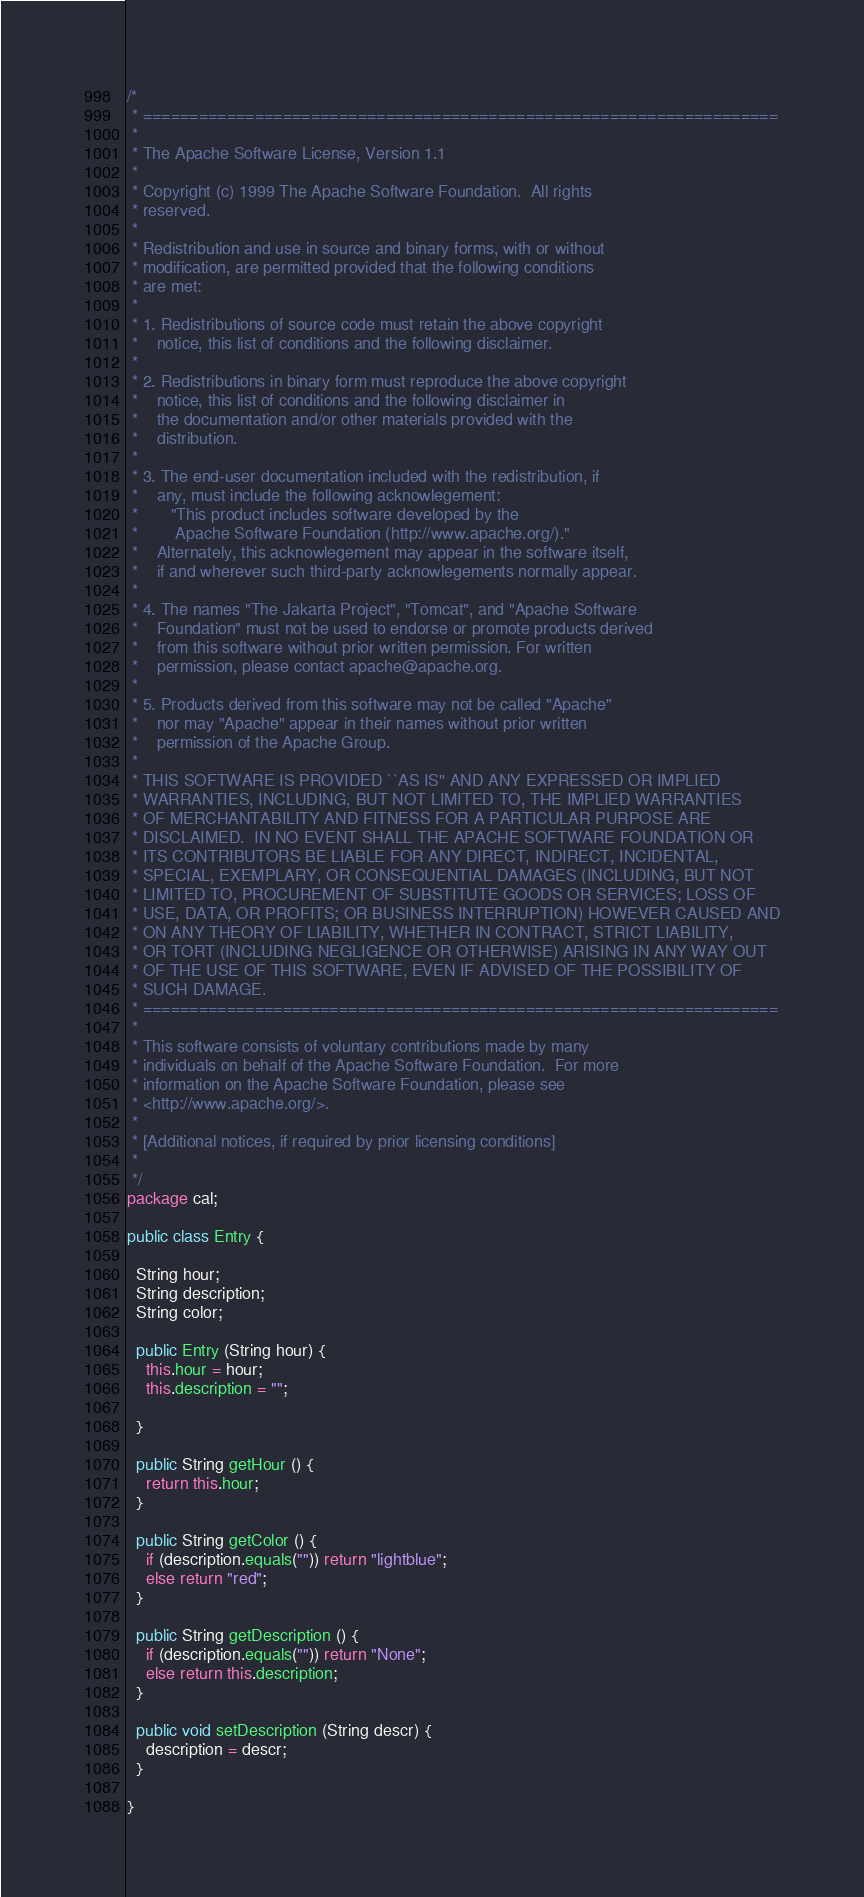<code> <loc_0><loc_0><loc_500><loc_500><_Java_>/*
 * ====================================================================
 *
 * The Apache Software License, Version 1.1
 *
 * Copyright (c) 1999 The Apache Software Foundation.  All rights 
 * reserved.
 *
 * Redistribution and use in source and binary forms, with or without
 * modification, are permitted provided that the following conditions
 * are met:
 *
 * 1. Redistributions of source code must retain the above copyright
 *    notice, this list of conditions and the following disclaimer. 
 *
 * 2. Redistributions in binary form must reproduce the above copyright
 *    notice, this list of conditions and the following disclaimer in
 *    the documentation and/or other materials provided with the
 *    distribution.
 *
 * 3. The end-user documentation included with the redistribution, if
 *    any, must include the following acknowlegement:  
 *       "This product includes software developed by the 
 *        Apache Software Foundation (http://www.apache.org/)."
 *    Alternately, this acknowlegement may appear in the software itself,
 *    if and wherever such third-party acknowlegements normally appear.
 *
 * 4. The names "The Jakarta Project", "Tomcat", and "Apache Software
 *    Foundation" must not be used to endorse or promote products derived
 *    from this software without prior written permission. For written 
 *    permission, please contact apache@apache.org.
 *
 * 5. Products derived from this software may not be called "Apache"
 *    nor may "Apache" appear in their names without prior written
 *    permission of the Apache Group.
 *
 * THIS SOFTWARE IS PROVIDED ``AS IS'' AND ANY EXPRESSED OR IMPLIED
 * WARRANTIES, INCLUDING, BUT NOT LIMITED TO, THE IMPLIED WARRANTIES
 * OF MERCHANTABILITY AND FITNESS FOR A PARTICULAR PURPOSE ARE
 * DISCLAIMED.  IN NO EVENT SHALL THE APACHE SOFTWARE FOUNDATION OR
 * ITS CONTRIBUTORS BE LIABLE FOR ANY DIRECT, INDIRECT, INCIDENTAL,
 * SPECIAL, EXEMPLARY, OR CONSEQUENTIAL DAMAGES (INCLUDING, BUT NOT
 * LIMITED TO, PROCUREMENT OF SUBSTITUTE GOODS OR SERVICES; LOSS OF
 * USE, DATA, OR PROFITS; OR BUSINESS INTERRUPTION) HOWEVER CAUSED AND
 * ON ANY THEORY OF LIABILITY, WHETHER IN CONTRACT, STRICT LIABILITY,
 * OR TORT (INCLUDING NEGLIGENCE OR OTHERWISE) ARISING IN ANY WAY OUT
 * OF THE USE OF THIS SOFTWARE, EVEN IF ADVISED OF THE POSSIBILITY OF
 * SUCH DAMAGE.
 * ====================================================================
 *
 * This software consists of voluntary contributions made by many
 * individuals on behalf of the Apache Software Foundation.  For more
 * information on the Apache Software Foundation, please see
 * <http://www.apache.org/>.
 *
 * [Additional notices, if required by prior licensing conditions]
 *
 */ 
package cal;

public class Entry {

  String hour;
  String description;
  String color;

  public Entry (String hour) {
    this.hour = hour;
    this.description = "";

  }

  public String getHour () {
    return this.hour;
  }

  public String getColor () {
    if (description.equals("")) return "lightblue";
    else return "red";
  }

  public String getDescription () {
    if (description.equals("")) return "None";
    else return this.description;
  }

  public void setDescription (String descr) {
    description = descr;
  }
 
}





</code> 